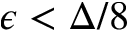Convert formula to latex. <formula><loc_0><loc_0><loc_500><loc_500>\epsilon < \Delta / 8</formula> 